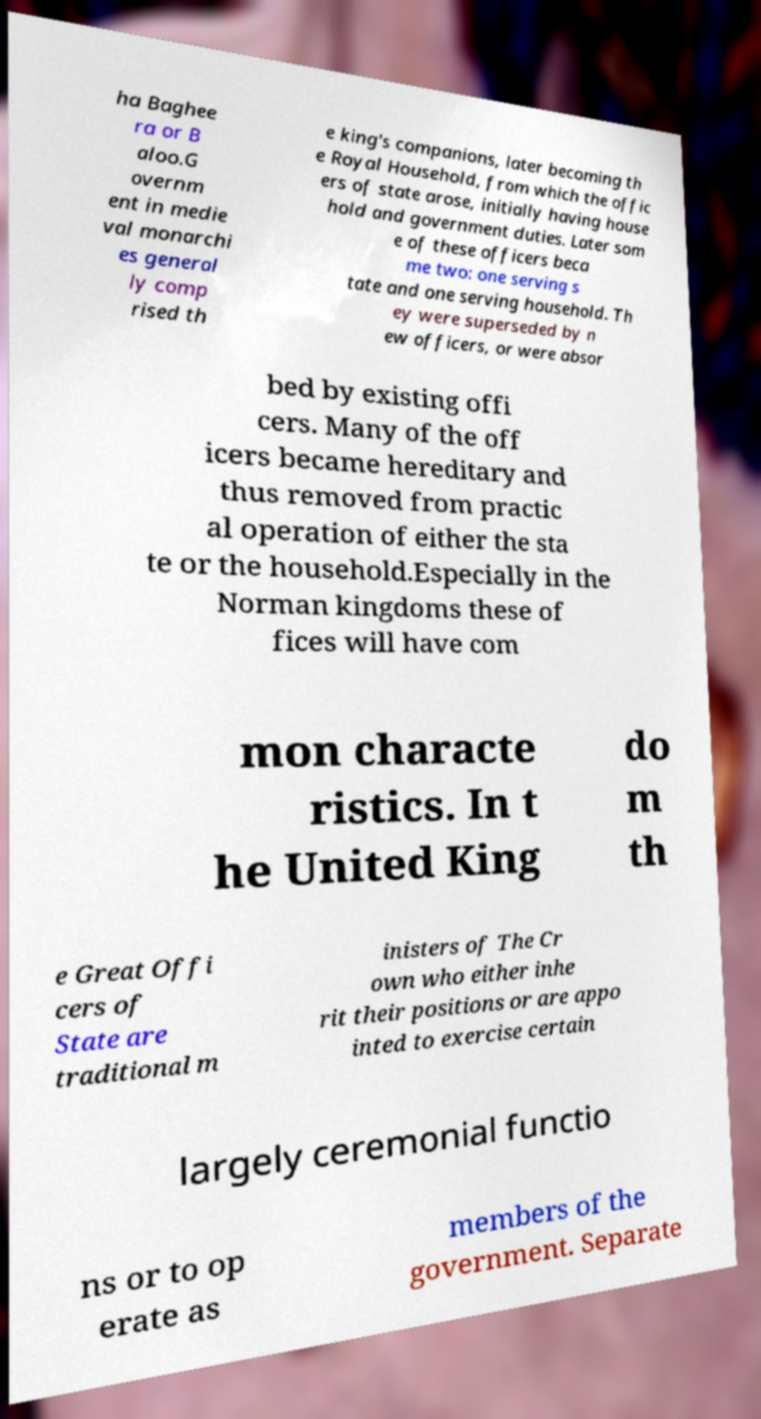Please identify and transcribe the text found in this image. ha Baghee ra or B aloo.G overnm ent in medie val monarchi es general ly comp rised th e king's companions, later becoming th e Royal Household, from which the offic ers of state arose, initially having house hold and government duties. Later som e of these officers beca me two: one serving s tate and one serving household. Th ey were superseded by n ew officers, or were absor bed by existing offi cers. Many of the off icers became hereditary and thus removed from practic al operation of either the sta te or the household.Especially in the Norman kingdoms these of fices will have com mon characte ristics. In t he United King do m th e Great Offi cers of State are traditional m inisters of The Cr own who either inhe rit their positions or are appo inted to exercise certain largely ceremonial functio ns or to op erate as members of the government. Separate 